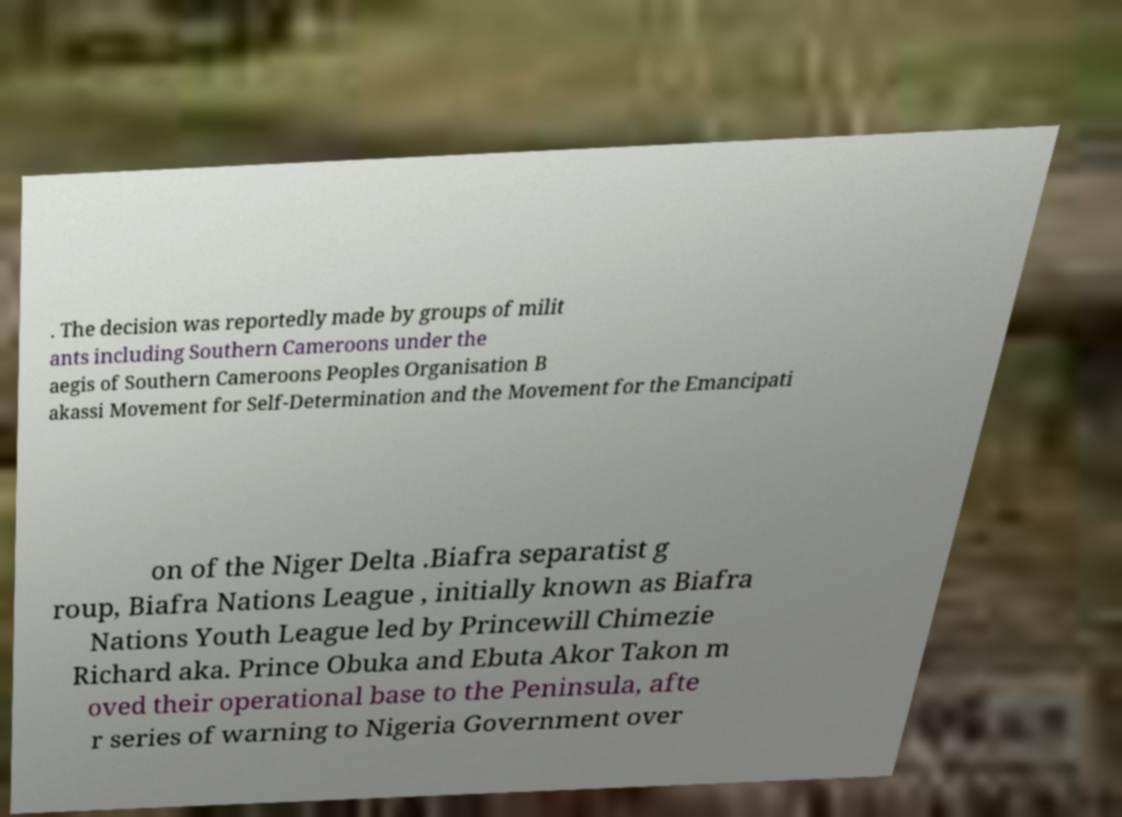For documentation purposes, I need the text within this image transcribed. Could you provide that? . The decision was reportedly made by groups of milit ants including Southern Cameroons under the aegis of Southern Cameroons Peoples Organisation B akassi Movement for Self-Determination and the Movement for the Emancipati on of the Niger Delta .Biafra separatist g roup, Biafra Nations League , initially known as Biafra Nations Youth League led by Princewill Chimezie Richard aka. Prince Obuka and Ebuta Akor Takon m oved their operational base to the Peninsula, afte r series of warning to Nigeria Government over 